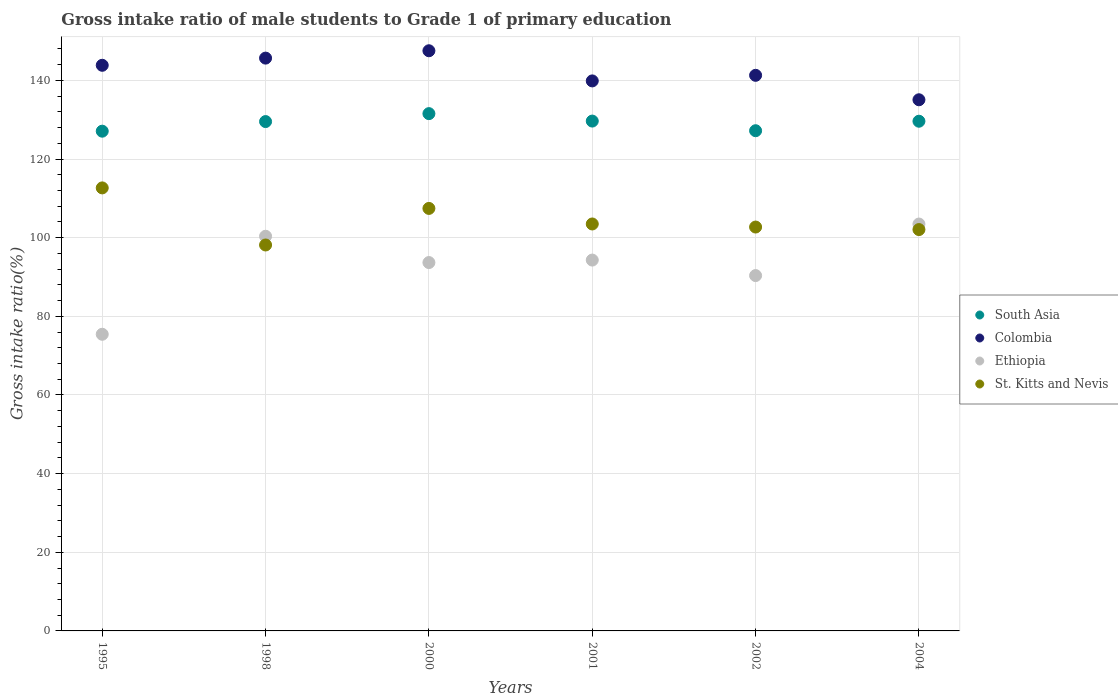How many different coloured dotlines are there?
Give a very brief answer. 4. What is the gross intake ratio in Ethiopia in 2000?
Keep it short and to the point. 93.67. Across all years, what is the maximum gross intake ratio in Colombia?
Offer a terse response. 147.53. Across all years, what is the minimum gross intake ratio in Ethiopia?
Offer a terse response. 75.43. In which year was the gross intake ratio in Ethiopia maximum?
Ensure brevity in your answer.  2004. What is the total gross intake ratio in St. Kitts and Nevis in the graph?
Provide a succinct answer. 626.48. What is the difference between the gross intake ratio in South Asia in 2000 and that in 2002?
Your answer should be very brief. 4.35. What is the difference between the gross intake ratio in Colombia in 2000 and the gross intake ratio in Ethiopia in 2001?
Provide a succinct answer. 53.23. What is the average gross intake ratio in Ethiopia per year?
Your answer should be very brief. 92.93. In the year 1995, what is the difference between the gross intake ratio in Colombia and gross intake ratio in South Asia?
Your answer should be compact. 16.76. What is the ratio of the gross intake ratio in St. Kitts and Nevis in 2000 to that in 2004?
Offer a very short reply. 1.05. Is the gross intake ratio in South Asia in 2000 less than that in 2004?
Offer a terse response. No. What is the difference between the highest and the second highest gross intake ratio in Colombia?
Give a very brief answer. 1.87. What is the difference between the highest and the lowest gross intake ratio in South Asia?
Provide a succinct answer. 4.46. Is the sum of the gross intake ratio in St. Kitts and Nevis in 1998 and 2000 greater than the maximum gross intake ratio in South Asia across all years?
Provide a short and direct response. Yes. Is the gross intake ratio in St. Kitts and Nevis strictly greater than the gross intake ratio in Colombia over the years?
Give a very brief answer. No. Does the graph contain grids?
Your answer should be very brief. Yes. Where does the legend appear in the graph?
Ensure brevity in your answer.  Center right. How many legend labels are there?
Make the answer very short. 4. How are the legend labels stacked?
Give a very brief answer. Vertical. What is the title of the graph?
Give a very brief answer. Gross intake ratio of male students to Grade 1 of primary education. What is the label or title of the Y-axis?
Your answer should be very brief. Gross intake ratio(%). What is the Gross intake ratio(%) of South Asia in 1995?
Give a very brief answer. 127.08. What is the Gross intake ratio(%) of Colombia in 1995?
Your answer should be very brief. 143.84. What is the Gross intake ratio(%) of Ethiopia in 1995?
Your answer should be compact. 75.43. What is the Gross intake ratio(%) in St. Kitts and Nevis in 1995?
Offer a terse response. 112.66. What is the Gross intake ratio(%) of South Asia in 1998?
Offer a very short reply. 129.52. What is the Gross intake ratio(%) in Colombia in 1998?
Make the answer very short. 145.66. What is the Gross intake ratio(%) in Ethiopia in 1998?
Provide a succinct answer. 100.36. What is the Gross intake ratio(%) of St. Kitts and Nevis in 1998?
Your answer should be compact. 98.14. What is the Gross intake ratio(%) in South Asia in 2000?
Make the answer very short. 131.54. What is the Gross intake ratio(%) of Colombia in 2000?
Offer a terse response. 147.53. What is the Gross intake ratio(%) of Ethiopia in 2000?
Make the answer very short. 93.67. What is the Gross intake ratio(%) in St. Kitts and Nevis in 2000?
Ensure brevity in your answer.  107.44. What is the Gross intake ratio(%) in South Asia in 2001?
Offer a very short reply. 129.65. What is the Gross intake ratio(%) of Colombia in 2001?
Keep it short and to the point. 139.86. What is the Gross intake ratio(%) of Ethiopia in 2001?
Provide a short and direct response. 94.31. What is the Gross intake ratio(%) of St. Kitts and Nevis in 2001?
Keep it short and to the point. 103.48. What is the Gross intake ratio(%) in South Asia in 2002?
Your answer should be very brief. 127.2. What is the Gross intake ratio(%) in Colombia in 2002?
Provide a short and direct response. 141.29. What is the Gross intake ratio(%) in Ethiopia in 2002?
Offer a very short reply. 90.36. What is the Gross intake ratio(%) of St. Kitts and Nevis in 2002?
Provide a succinct answer. 102.7. What is the Gross intake ratio(%) in South Asia in 2004?
Your answer should be compact. 129.61. What is the Gross intake ratio(%) of Colombia in 2004?
Your answer should be very brief. 135.07. What is the Gross intake ratio(%) in Ethiopia in 2004?
Your response must be concise. 103.47. What is the Gross intake ratio(%) of St. Kitts and Nevis in 2004?
Provide a succinct answer. 102.06. Across all years, what is the maximum Gross intake ratio(%) of South Asia?
Give a very brief answer. 131.54. Across all years, what is the maximum Gross intake ratio(%) of Colombia?
Provide a short and direct response. 147.53. Across all years, what is the maximum Gross intake ratio(%) in Ethiopia?
Your answer should be compact. 103.47. Across all years, what is the maximum Gross intake ratio(%) of St. Kitts and Nevis?
Offer a very short reply. 112.66. Across all years, what is the minimum Gross intake ratio(%) of South Asia?
Ensure brevity in your answer.  127.08. Across all years, what is the minimum Gross intake ratio(%) of Colombia?
Offer a terse response. 135.07. Across all years, what is the minimum Gross intake ratio(%) of Ethiopia?
Provide a short and direct response. 75.43. Across all years, what is the minimum Gross intake ratio(%) of St. Kitts and Nevis?
Make the answer very short. 98.14. What is the total Gross intake ratio(%) in South Asia in the graph?
Offer a terse response. 774.61. What is the total Gross intake ratio(%) in Colombia in the graph?
Keep it short and to the point. 853.25. What is the total Gross intake ratio(%) of Ethiopia in the graph?
Your response must be concise. 557.6. What is the total Gross intake ratio(%) of St. Kitts and Nevis in the graph?
Offer a terse response. 626.48. What is the difference between the Gross intake ratio(%) of South Asia in 1995 and that in 1998?
Give a very brief answer. -2.45. What is the difference between the Gross intake ratio(%) in Colombia in 1995 and that in 1998?
Provide a short and direct response. -1.82. What is the difference between the Gross intake ratio(%) of Ethiopia in 1995 and that in 1998?
Ensure brevity in your answer.  -24.93. What is the difference between the Gross intake ratio(%) of St. Kitts and Nevis in 1995 and that in 1998?
Provide a short and direct response. 14.52. What is the difference between the Gross intake ratio(%) of South Asia in 1995 and that in 2000?
Offer a very short reply. -4.46. What is the difference between the Gross intake ratio(%) of Colombia in 1995 and that in 2000?
Give a very brief answer. -3.7. What is the difference between the Gross intake ratio(%) in Ethiopia in 1995 and that in 2000?
Provide a short and direct response. -18.24. What is the difference between the Gross intake ratio(%) of St. Kitts and Nevis in 1995 and that in 2000?
Provide a short and direct response. 5.22. What is the difference between the Gross intake ratio(%) in South Asia in 1995 and that in 2001?
Provide a succinct answer. -2.57. What is the difference between the Gross intake ratio(%) in Colombia in 1995 and that in 2001?
Your answer should be compact. 3.97. What is the difference between the Gross intake ratio(%) of Ethiopia in 1995 and that in 2001?
Offer a terse response. -18.87. What is the difference between the Gross intake ratio(%) of St. Kitts and Nevis in 1995 and that in 2001?
Your response must be concise. 9.17. What is the difference between the Gross intake ratio(%) of South Asia in 1995 and that in 2002?
Make the answer very short. -0.12. What is the difference between the Gross intake ratio(%) in Colombia in 1995 and that in 2002?
Offer a very short reply. 2.55. What is the difference between the Gross intake ratio(%) in Ethiopia in 1995 and that in 2002?
Provide a succinct answer. -14.93. What is the difference between the Gross intake ratio(%) in St. Kitts and Nevis in 1995 and that in 2002?
Offer a very short reply. 9.95. What is the difference between the Gross intake ratio(%) of South Asia in 1995 and that in 2004?
Make the answer very short. -2.53. What is the difference between the Gross intake ratio(%) of Colombia in 1995 and that in 2004?
Keep it short and to the point. 8.77. What is the difference between the Gross intake ratio(%) of Ethiopia in 1995 and that in 2004?
Offer a terse response. -28.03. What is the difference between the Gross intake ratio(%) of St. Kitts and Nevis in 1995 and that in 2004?
Give a very brief answer. 10.59. What is the difference between the Gross intake ratio(%) in South Asia in 1998 and that in 2000?
Give a very brief answer. -2.02. What is the difference between the Gross intake ratio(%) of Colombia in 1998 and that in 2000?
Provide a succinct answer. -1.87. What is the difference between the Gross intake ratio(%) in Ethiopia in 1998 and that in 2000?
Ensure brevity in your answer.  6.69. What is the difference between the Gross intake ratio(%) in St. Kitts and Nevis in 1998 and that in 2000?
Give a very brief answer. -9.3. What is the difference between the Gross intake ratio(%) of South Asia in 1998 and that in 2001?
Give a very brief answer. -0.13. What is the difference between the Gross intake ratio(%) of Colombia in 1998 and that in 2001?
Your answer should be compact. 5.8. What is the difference between the Gross intake ratio(%) of Ethiopia in 1998 and that in 2001?
Ensure brevity in your answer.  6.05. What is the difference between the Gross intake ratio(%) in St. Kitts and Nevis in 1998 and that in 2001?
Give a very brief answer. -5.34. What is the difference between the Gross intake ratio(%) of South Asia in 1998 and that in 2002?
Give a very brief answer. 2.33. What is the difference between the Gross intake ratio(%) in Colombia in 1998 and that in 2002?
Provide a short and direct response. 4.37. What is the difference between the Gross intake ratio(%) of Ethiopia in 1998 and that in 2002?
Offer a very short reply. 10. What is the difference between the Gross intake ratio(%) of St. Kitts and Nevis in 1998 and that in 2002?
Offer a very short reply. -4.56. What is the difference between the Gross intake ratio(%) in South Asia in 1998 and that in 2004?
Offer a very short reply. -0.09. What is the difference between the Gross intake ratio(%) of Colombia in 1998 and that in 2004?
Your response must be concise. 10.59. What is the difference between the Gross intake ratio(%) in Ethiopia in 1998 and that in 2004?
Provide a succinct answer. -3.11. What is the difference between the Gross intake ratio(%) in St. Kitts and Nevis in 1998 and that in 2004?
Your answer should be compact. -3.92. What is the difference between the Gross intake ratio(%) in South Asia in 2000 and that in 2001?
Your response must be concise. 1.89. What is the difference between the Gross intake ratio(%) in Colombia in 2000 and that in 2001?
Offer a very short reply. 7.67. What is the difference between the Gross intake ratio(%) in Ethiopia in 2000 and that in 2001?
Your response must be concise. -0.63. What is the difference between the Gross intake ratio(%) of St. Kitts and Nevis in 2000 and that in 2001?
Keep it short and to the point. 3.95. What is the difference between the Gross intake ratio(%) of South Asia in 2000 and that in 2002?
Your answer should be very brief. 4.35. What is the difference between the Gross intake ratio(%) in Colombia in 2000 and that in 2002?
Your answer should be compact. 6.25. What is the difference between the Gross intake ratio(%) in Ethiopia in 2000 and that in 2002?
Ensure brevity in your answer.  3.31. What is the difference between the Gross intake ratio(%) in St. Kitts and Nevis in 2000 and that in 2002?
Provide a succinct answer. 4.74. What is the difference between the Gross intake ratio(%) in South Asia in 2000 and that in 2004?
Ensure brevity in your answer.  1.93. What is the difference between the Gross intake ratio(%) of Colombia in 2000 and that in 2004?
Your answer should be compact. 12.46. What is the difference between the Gross intake ratio(%) in Ethiopia in 2000 and that in 2004?
Ensure brevity in your answer.  -9.8. What is the difference between the Gross intake ratio(%) of St. Kitts and Nevis in 2000 and that in 2004?
Ensure brevity in your answer.  5.38. What is the difference between the Gross intake ratio(%) of South Asia in 2001 and that in 2002?
Offer a very short reply. 2.45. What is the difference between the Gross intake ratio(%) of Colombia in 2001 and that in 2002?
Offer a terse response. -1.42. What is the difference between the Gross intake ratio(%) in Ethiopia in 2001 and that in 2002?
Provide a short and direct response. 3.94. What is the difference between the Gross intake ratio(%) of St. Kitts and Nevis in 2001 and that in 2002?
Your response must be concise. 0.78. What is the difference between the Gross intake ratio(%) in South Asia in 2001 and that in 2004?
Provide a short and direct response. 0.04. What is the difference between the Gross intake ratio(%) of Colombia in 2001 and that in 2004?
Offer a very short reply. 4.79. What is the difference between the Gross intake ratio(%) of Ethiopia in 2001 and that in 2004?
Ensure brevity in your answer.  -9.16. What is the difference between the Gross intake ratio(%) of St. Kitts and Nevis in 2001 and that in 2004?
Give a very brief answer. 1.42. What is the difference between the Gross intake ratio(%) in South Asia in 2002 and that in 2004?
Make the answer very short. -2.42. What is the difference between the Gross intake ratio(%) in Colombia in 2002 and that in 2004?
Your answer should be very brief. 6.22. What is the difference between the Gross intake ratio(%) of Ethiopia in 2002 and that in 2004?
Ensure brevity in your answer.  -13.11. What is the difference between the Gross intake ratio(%) of St. Kitts and Nevis in 2002 and that in 2004?
Provide a short and direct response. 0.64. What is the difference between the Gross intake ratio(%) in South Asia in 1995 and the Gross intake ratio(%) in Colombia in 1998?
Make the answer very short. -18.58. What is the difference between the Gross intake ratio(%) in South Asia in 1995 and the Gross intake ratio(%) in Ethiopia in 1998?
Your response must be concise. 26.72. What is the difference between the Gross intake ratio(%) in South Asia in 1995 and the Gross intake ratio(%) in St. Kitts and Nevis in 1998?
Provide a short and direct response. 28.94. What is the difference between the Gross intake ratio(%) of Colombia in 1995 and the Gross intake ratio(%) of Ethiopia in 1998?
Provide a succinct answer. 43.48. What is the difference between the Gross intake ratio(%) in Colombia in 1995 and the Gross intake ratio(%) in St. Kitts and Nevis in 1998?
Your answer should be compact. 45.7. What is the difference between the Gross intake ratio(%) in Ethiopia in 1995 and the Gross intake ratio(%) in St. Kitts and Nevis in 1998?
Keep it short and to the point. -22.71. What is the difference between the Gross intake ratio(%) in South Asia in 1995 and the Gross intake ratio(%) in Colombia in 2000?
Your response must be concise. -20.45. What is the difference between the Gross intake ratio(%) of South Asia in 1995 and the Gross intake ratio(%) of Ethiopia in 2000?
Keep it short and to the point. 33.41. What is the difference between the Gross intake ratio(%) in South Asia in 1995 and the Gross intake ratio(%) in St. Kitts and Nevis in 2000?
Make the answer very short. 19.64. What is the difference between the Gross intake ratio(%) of Colombia in 1995 and the Gross intake ratio(%) of Ethiopia in 2000?
Your answer should be compact. 50.16. What is the difference between the Gross intake ratio(%) in Colombia in 1995 and the Gross intake ratio(%) in St. Kitts and Nevis in 2000?
Keep it short and to the point. 36.4. What is the difference between the Gross intake ratio(%) in Ethiopia in 1995 and the Gross intake ratio(%) in St. Kitts and Nevis in 2000?
Offer a terse response. -32. What is the difference between the Gross intake ratio(%) of South Asia in 1995 and the Gross intake ratio(%) of Colombia in 2001?
Your response must be concise. -12.79. What is the difference between the Gross intake ratio(%) in South Asia in 1995 and the Gross intake ratio(%) in Ethiopia in 2001?
Your answer should be very brief. 32.77. What is the difference between the Gross intake ratio(%) in South Asia in 1995 and the Gross intake ratio(%) in St. Kitts and Nevis in 2001?
Your answer should be compact. 23.6. What is the difference between the Gross intake ratio(%) in Colombia in 1995 and the Gross intake ratio(%) in Ethiopia in 2001?
Keep it short and to the point. 49.53. What is the difference between the Gross intake ratio(%) in Colombia in 1995 and the Gross intake ratio(%) in St. Kitts and Nevis in 2001?
Give a very brief answer. 40.35. What is the difference between the Gross intake ratio(%) in Ethiopia in 1995 and the Gross intake ratio(%) in St. Kitts and Nevis in 2001?
Keep it short and to the point. -28.05. What is the difference between the Gross intake ratio(%) in South Asia in 1995 and the Gross intake ratio(%) in Colombia in 2002?
Make the answer very short. -14.21. What is the difference between the Gross intake ratio(%) in South Asia in 1995 and the Gross intake ratio(%) in Ethiopia in 2002?
Offer a terse response. 36.72. What is the difference between the Gross intake ratio(%) of South Asia in 1995 and the Gross intake ratio(%) of St. Kitts and Nevis in 2002?
Provide a short and direct response. 24.38. What is the difference between the Gross intake ratio(%) in Colombia in 1995 and the Gross intake ratio(%) in Ethiopia in 2002?
Offer a terse response. 53.47. What is the difference between the Gross intake ratio(%) in Colombia in 1995 and the Gross intake ratio(%) in St. Kitts and Nevis in 2002?
Keep it short and to the point. 41.13. What is the difference between the Gross intake ratio(%) of Ethiopia in 1995 and the Gross intake ratio(%) of St. Kitts and Nevis in 2002?
Ensure brevity in your answer.  -27.27. What is the difference between the Gross intake ratio(%) of South Asia in 1995 and the Gross intake ratio(%) of Colombia in 2004?
Offer a terse response. -7.99. What is the difference between the Gross intake ratio(%) of South Asia in 1995 and the Gross intake ratio(%) of Ethiopia in 2004?
Provide a succinct answer. 23.61. What is the difference between the Gross intake ratio(%) of South Asia in 1995 and the Gross intake ratio(%) of St. Kitts and Nevis in 2004?
Provide a succinct answer. 25.02. What is the difference between the Gross intake ratio(%) of Colombia in 1995 and the Gross intake ratio(%) of Ethiopia in 2004?
Offer a terse response. 40.37. What is the difference between the Gross intake ratio(%) in Colombia in 1995 and the Gross intake ratio(%) in St. Kitts and Nevis in 2004?
Provide a short and direct response. 41.77. What is the difference between the Gross intake ratio(%) of Ethiopia in 1995 and the Gross intake ratio(%) of St. Kitts and Nevis in 2004?
Offer a very short reply. -26.63. What is the difference between the Gross intake ratio(%) in South Asia in 1998 and the Gross intake ratio(%) in Colombia in 2000?
Offer a very short reply. -18.01. What is the difference between the Gross intake ratio(%) of South Asia in 1998 and the Gross intake ratio(%) of Ethiopia in 2000?
Provide a short and direct response. 35.85. What is the difference between the Gross intake ratio(%) of South Asia in 1998 and the Gross intake ratio(%) of St. Kitts and Nevis in 2000?
Give a very brief answer. 22.09. What is the difference between the Gross intake ratio(%) of Colombia in 1998 and the Gross intake ratio(%) of Ethiopia in 2000?
Ensure brevity in your answer.  51.99. What is the difference between the Gross intake ratio(%) of Colombia in 1998 and the Gross intake ratio(%) of St. Kitts and Nevis in 2000?
Provide a short and direct response. 38.22. What is the difference between the Gross intake ratio(%) of Ethiopia in 1998 and the Gross intake ratio(%) of St. Kitts and Nevis in 2000?
Your answer should be very brief. -7.08. What is the difference between the Gross intake ratio(%) of South Asia in 1998 and the Gross intake ratio(%) of Colombia in 2001?
Provide a short and direct response. -10.34. What is the difference between the Gross intake ratio(%) in South Asia in 1998 and the Gross intake ratio(%) in Ethiopia in 2001?
Offer a very short reply. 35.22. What is the difference between the Gross intake ratio(%) of South Asia in 1998 and the Gross intake ratio(%) of St. Kitts and Nevis in 2001?
Keep it short and to the point. 26.04. What is the difference between the Gross intake ratio(%) in Colombia in 1998 and the Gross intake ratio(%) in Ethiopia in 2001?
Keep it short and to the point. 51.35. What is the difference between the Gross intake ratio(%) of Colombia in 1998 and the Gross intake ratio(%) of St. Kitts and Nevis in 2001?
Provide a succinct answer. 42.18. What is the difference between the Gross intake ratio(%) in Ethiopia in 1998 and the Gross intake ratio(%) in St. Kitts and Nevis in 2001?
Ensure brevity in your answer.  -3.12. What is the difference between the Gross intake ratio(%) in South Asia in 1998 and the Gross intake ratio(%) in Colombia in 2002?
Provide a short and direct response. -11.76. What is the difference between the Gross intake ratio(%) of South Asia in 1998 and the Gross intake ratio(%) of Ethiopia in 2002?
Offer a terse response. 39.16. What is the difference between the Gross intake ratio(%) in South Asia in 1998 and the Gross intake ratio(%) in St. Kitts and Nevis in 2002?
Your response must be concise. 26.82. What is the difference between the Gross intake ratio(%) in Colombia in 1998 and the Gross intake ratio(%) in Ethiopia in 2002?
Provide a succinct answer. 55.3. What is the difference between the Gross intake ratio(%) of Colombia in 1998 and the Gross intake ratio(%) of St. Kitts and Nevis in 2002?
Provide a short and direct response. 42.96. What is the difference between the Gross intake ratio(%) of Ethiopia in 1998 and the Gross intake ratio(%) of St. Kitts and Nevis in 2002?
Ensure brevity in your answer.  -2.34. What is the difference between the Gross intake ratio(%) of South Asia in 1998 and the Gross intake ratio(%) of Colombia in 2004?
Your answer should be very brief. -5.54. What is the difference between the Gross intake ratio(%) in South Asia in 1998 and the Gross intake ratio(%) in Ethiopia in 2004?
Provide a succinct answer. 26.06. What is the difference between the Gross intake ratio(%) in South Asia in 1998 and the Gross intake ratio(%) in St. Kitts and Nevis in 2004?
Offer a very short reply. 27.46. What is the difference between the Gross intake ratio(%) in Colombia in 1998 and the Gross intake ratio(%) in Ethiopia in 2004?
Provide a short and direct response. 42.19. What is the difference between the Gross intake ratio(%) in Colombia in 1998 and the Gross intake ratio(%) in St. Kitts and Nevis in 2004?
Provide a short and direct response. 43.6. What is the difference between the Gross intake ratio(%) in Ethiopia in 1998 and the Gross intake ratio(%) in St. Kitts and Nevis in 2004?
Your answer should be compact. -1.7. What is the difference between the Gross intake ratio(%) of South Asia in 2000 and the Gross intake ratio(%) of Colombia in 2001?
Give a very brief answer. -8.32. What is the difference between the Gross intake ratio(%) in South Asia in 2000 and the Gross intake ratio(%) in Ethiopia in 2001?
Provide a succinct answer. 37.24. What is the difference between the Gross intake ratio(%) of South Asia in 2000 and the Gross intake ratio(%) of St. Kitts and Nevis in 2001?
Your answer should be very brief. 28.06. What is the difference between the Gross intake ratio(%) in Colombia in 2000 and the Gross intake ratio(%) in Ethiopia in 2001?
Offer a very short reply. 53.23. What is the difference between the Gross intake ratio(%) in Colombia in 2000 and the Gross intake ratio(%) in St. Kitts and Nevis in 2001?
Provide a succinct answer. 44.05. What is the difference between the Gross intake ratio(%) in Ethiopia in 2000 and the Gross intake ratio(%) in St. Kitts and Nevis in 2001?
Provide a succinct answer. -9.81. What is the difference between the Gross intake ratio(%) of South Asia in 2000 and the Gross intake ratio(%) of Colombia in 2002?
Your answer should be compact. -9.74. What is the difference between the Gross intake ratio(%) of South Asia in 2000 and the Gross intake ratio(%) of Ethiopia in 2002?
Offer a very short reply. 41.18. What is the difference between the Gross intake ratio(%) of South Asia in 2000 and the Gross intake ratio(%) of St. Kitts and Nevis in 2002?
Provide a short and direct response. 28.84. What is the difference between the Gross intake ratio(%) of Colombia in 2000 and the Gross intake ratio(%) of Ethiopia in 2002?
Your answer should be compact. 57.17. What is the difference between the Gross intake ratio(%) of Colombia in 2000 and the Gross intake ratio(%) of St. Kitts and Nevis in 2002?
Provide a short and direct response. 44.83. What is the difference between the Gross intake ratio(%) of Ethiopia in 2000 and the Gross intake ratio(%) of St. Kitts and Nevis in 2002?
Give a very brief answer. -9.03. What is the difference between the Gross intake ratio(%) of South Asia in 2000 and the Gross intake ratio(%) of Colombia in 2004?
Provide a short and direct response. -3.53. What is the difference between the Gross intake ratio(%) of South Asia in 2000 and the Gross intake ratio(%) of Ethiopia in 2004?
Your answer should be very brief. 28.07. What is the difference between the Gross intake ratio(%) in South Asia in 2000 and the Gross intake ratio(%) in St. Kitts and Nevis in 2004?
Your response must be concise. 29.48. What is the difference between the Gross intake ratio(%) in Colombia in 2000 and the Gross intake ratio(%) in Ethiopia in 2004?
Offer a very short reply. 44.07. What is the difference between the Gross intake ratio(%) in Colombia in 2000 and the Gross intake ratio(%) in St. Kitts and Nevis in 2004?
Ensure brevity in your answer.  45.47. What is the difference between the Gross intake ratio(%) in Ethiopia in 2000 and the Gross intake ratio(%) in St. Kitts and Nevis in 2004?
Provide a succinct answer. -8.39. What is the difference between the Gross intake ratio(%) of South Asia in 2001 and the Gross intake ratio(%) of Colombia in 2002?
Your response must be concise. -11.64. What is the difference between the Gross intake ratio(%) in South Asia in 2001 and the Gross intake ratio(%) in Ethiopia in 2002?
Your answer should be compact. 39.29. What is the difference between the Gross intake ratio(%) of South Asia in 2001 and the Gross intake ratio(%) of St. Kitts and Nevis in 2002?
Make the answer very short. 26.95. What is the difference between the Gross intake ratio(%) in Colombia in 2001 and the Gross intake ratio(%) in Ethiopia in 2002?
Provide a short and direct response. 49.5. What is the difference between the Gross intake ratio(%) of Colombia in 2001 and the Gross intake ratio(%) of St. Kitts and Nevis in 2002?
Make the answer very short. 37.16. What is the difference between the Gross intake ratio(%) of Ethiopia in 2001 and the Gross intake ratio(%) of St. Kitts and Nevis in 2002?
Your response must be concise. -8.4. What is the difference between the Gross intake ratio(%) in South Asia in 2001 and the Gross intake ratio(%) in Colombia in 2004?
Offer a terse response. -5.42. What is the difference between the Gross intake ratio(%) in South Asia in 2001 and the Gross intake ratio(%) in Ethiopia in 2004?
Offer a terse response. 26.18. What is the difference between the Gross intake ratio(%) in South Asia in 2001 and the Gross intake ratio(%) in St. Kitts and Nevis in 2004?
Offer a terse response. 27.59. What is the difference between the Gross intake ratio(%) in Colombia in 2001 and the Gross intake ratio(%) in Ethiopia in 2004?
Give a very brief answer. 36.4. What is the difference between the Gross intake ratio(%) of Colombia in 2001 and the Gross intake ratio(%) of St. Kitts and Nevis in 2004?
Provide a short and direct response. 37.8. What is the difference between the Gross intake ratio(%) in Ethiopia in 2001 and the Gross intake ratio(%) in St. Kitts and Nevis in 2004?
Your answer should be very brief. -7.76. What is the difference between the Gross intake ratio(%) of South Asia in 2002 and the Gross intake ratio(%) of Colombia in 2004?
Keep it short and to the point. -7.87. What is the difference between the Gross intake ratio(%) of South Asia in 2002 and the Gross intake ratio(%) of Ethiopia in 2004?
Make the answer very short. 23.73. What is the difference between the Gross intake ratio(%) in South Asia in 2002 and the Gross intake ratio(%) in St. Kitts and Nevis in 2004?
Provide a short and direct response. 25.14. What is the difference between the Gross intake ratio(%) in Colombia in 2002 and the Gross intake ratio(%) in Ethiopia in 2004?
Offer a very short reply. 37.82. What is the difference between the Gross intake ratio(%) of Colombia in 2002 and the Gross intake ratio(%) of St. Kitts and Nevis in 2004?
Your answer should be very brief. 39.22. What is the difference between the Gross intake ratio(%) in Ethiopia in 2002 and the Gross intake ratio(%) in St. Kitts and Nevis in 2004?
Give a very brief answer. -11.7. What is the average Gross intake ratio(%) of South Asia per year?
Keep it short and to the point. 129.1. What is the average Gross intake ratio(%) in Colombia per year?
Your answer should be very brief. 142.21. What is the average Gross intake ratio(%) of Ethiopia per year?
Keep it short and to the point. 92.93. What is the average Gross intake ratio(%) of St. Kitts and Nevis per year?
Your answer should be compact. 104.41. In the year 1995, what is the difference between the Gross intake ratio(%) of South Asia and Gross intake ratio(%) of Colombia?
Keep it short and to the point. -16.76. In the year 1995, what is the difference between the Gross intake ratio(%) of South Asia and Gross intake ratio(%) of Ethiopia?
Offer a terse response. 51.64. In the year 1995, what is the difference between the Gross intake ratio(%) in South Asia and Gross intake ratio(%) in St. Kitts and Nevis?
Ensure brevity in your answer.  14.42. In the year 1995, what is the difference between the Gross intake ratio(%) in Colombia and Gross intake ratio(%) in Ethiopia?
Your answer should be compact. 68.4. In the year 1995, what is the difference between the Gross intake ratio(%) of Colombia and Gross intake ratio(%) of St. Kitts and Nevis?
Give a very brief answer. 31.18. In the year 1995, what is the difference between the Gross intake ratio(%) of Ethiopia and Gross intake ratio(%) of St. Kitts and Nevis?
Keep it short and to the point. -37.22. In the year 1998, what is the difference between the Gross intake ratio(%) of South Asia and Gross intake ratio(%) of Colombia?
Your answer should be very brief. -16.14. In the year 1998, what is the difference between the Gross intake ratio(%) in South Asia and Gross intake ratio(%) in Ethiopia?
Your answer should be very brief. 29.16. In the year 1998, what is the difference between the Gross intake ratio(%) of South Asia and Gross intake ratio(%) of St. Kitts and Nevis?
Provide a succinct answer. 31.38. In the year 1998, what is the difference between the Gross intake ratio(%) of Colombia and Gross intake ratio(%) of Ethiopia?
Make the answer very short. 45.3. In the year 1998, what is the difference between the Gross intake ratio(%) of Colombia and Gross intake ratio(%) of St. Kitts and Nevis?
Keep it short and to the point. 47.52. In the year 1998, what is the difference between the Gross intake ratio(%) in Ethiopia and Gross intake ratio(%) in St. Kitts and Nevis?
Your answer should be compact. 2.22. In the year 2000, what is the difference between the Gross intake ratio(%) of South Asia and Gross intake ratio(%) of Colombia?
Your answer should be very brief. -15.99. In the year 2000, what is the difference between the Gross intake ratio(%) of South Asia and Gross intake ratio(%) of Ethiopia?
Provide a short and direct response. 37.87. In the year 2000, what is the difference between the Gross intake ratio(%) in South Asia and Gross intake ratio(%) in St. Kitts and Nevis?
Give a very brief answer. 24.1. In the year 2000, what is the difference between the Gross intake ratio(%) of Colombia and Gross intake ratio(%) of Ethiopia?
Your response must be concise. 53.86. In the year 2000, what is the difference between the Gross intake ratio(%) in Colombia and Gross intake ratio(%) in St. Kitts and Nevis?
Offer a very short reply. 40.09. In the year 2000, what is the difference between the Gross intake ratio(%) in Ethiopia and Gross intake ratio(%) in St. Kitts and Nevis?
Give a very brief answer. -13.77. In the year 2001, what is the difference between the Gross intake ratio(%) of South Asia and Gross intake ratio(%) of Colombia?
Make the answer very short. -10.21. In the year 2001, what is the difference between the Gross intake ratio(%) of South Asia and Gross intake ratio(%) of Ethiopia?
Provide a short and direct response. 35.34. In the year 2001, what is the difference between the Gross intake ratio(%) in South Asia and Gross intake ratio(%) in St. Kitts and Nevis?
Your response must be concise. 26.17. In the year 2001, what is the difference between the Gross intake ratio(%) of Colombia and Gross intake ratio(%) of Ethiopia?
Your response must be concise. 45.56. In the year 2001, what is the difference between the Gross intake ratio(%) in Colombia and Gross intake ratio(%) in St. Kitts and Nevis?
Your answer should be very brief. 36.38. In the year 2001, what is the difference between the Gross intake ratio(%) in Ethiopia and Gross intake ratio(%) in St. Kitts and Nevis?
Your answer should be compact. -9.18. In the year 2002, what is the difference between the Gross intake ratio(%) in South Asia and Gross intake ratio(%) in Colombia?
Offer a very short reply. -14.09. In the year 2002, what is the difference between the Gross intake ratio(%) in South Asia and Gross intake ratio(%) in Ethiopia?
Your answer should be very brief. 36.83. In the year 2002, what is the difference between the Gross intake ratio(%) in South Asia and Gross intake ratio(%) in St. Kitts and Nevis?
Give a very brief answer. 24.49. In the year 2002, what is the difference between the Gross intake ratio(%) in Colombia and Gross intake ratio(%) in Ethiopia?
Give a very brief answer. 50.92. In the year 2002, what is the difference between the Gross intake ratio(%) in Colombia and Gross intake ratio(%) in St. Kitts and Nevis?
Keep it short and to the point. 38.58. In the year 2002, what is the difference between the Gross intake ratio(%) in Ethiopia and Gross intake ratio(%) in St. Kitts and Nevis?
Keep it short and to the point. -12.34. In the year 2004, what is the difference between the Gross intake ratio(%) of South Asia and Gross intake ratio(%) of Colombia?
Your answer should be compact. -5.46. In the year 2004, what is the difference between the Gross intake ratio(%) in South Asia and Gross intake ratio(%) in Ethiopia?
Give a very brief answer. 26.14. In the year 2004, what is the difference between the Gross intake ratio(%) in South Asia and Gross intake ratio(%) in St. Kitts and Nevis?
Ensure brevity in your answer.  27.55. In the year 2004, what is the difference between the Gross intake ratio(%) of Colombia and Gross intake ratio(%) of Ethiopia?
Ensure brevity in your answer.  31.6. In the year 2004, what is the difference between the Gross intake ratio(%) in Colombia and Gross intake ratio(%) in St. Kitts and Nevis?
Provide a short and direct response. 33.01. In the year 2004, what is the difference between the Gross intake ratio(%) in Ethiopia and Gross intake ratio(%) in St. Kitts and Nevis?
Offer a terse response. 1.41. What is the ratio of the Gross intake ratio(%) of South Asia in 1995 to that in 1998?
Keep it short and to the point. 0.98. What is the ratio of the Gross intake ratio(%) in Colombia in 1995 to that in 1998?
Provide a short and direct response. 0.99. What is the ratio of the Gross intake ratio(%) of Ethiopia in 1995 to that in 1998?
Offer a very short reply. 0.75. What is the ratio of the Gross intake ratio(%) of St. Kitts and Nevis in 1995 to that in 1998?
Give a very brief answer. 1.15. What is the ratio of the Gross intake ratio(%) of South Asia in 1995 to that in 2000?
Offer a very short reply. 0.97. What is the ratio of the Gross intake ratio(%) in Colombia in 1995 to that in 2000?
Your answer should be very brief. 0.97. What is the ratio of the Gross intake ratio(%) in Ethiopia in 1995 to that in 2000?
Offer a very short reply. 0.81. What is the ratio of the Gross intake ratio(%) in St. Kitts and Nevis in 1995 to that in 2000?
Give a very brief answer. 1.05. What is the ratio of the Gross intake ratio(%) in South Asia in 1995 to that in 2001?
Ensure brevity in your answer.  0.98. What is the ratio of the Gross intake ratio(%) in Colombia in 1995 to that in 2001?
Offer a terse response. 1.03. What is the ratio of the Gross intake ratio(%) of Ethiopia in 1995 to that in 2001?
Your answer should be compact. 0.8. What is the ratio of the Gross intake ratio(%) in St. Kitts and Nevis in 1995 to that in 2001?
Ensure brevity in your answer.  1.09. What is the ratio of the Gross intake ratio(%) in South Asia in 1995 to that in 2002?
Your response must be concise. 1. What is the ratio of the Gross intake ratio(%) of Colombia in 1995 to that in 2002?
Offer a very short reply. 1.02. What is the ratio of the Gross intake ratio(%) of Ethiopia in 1995 to that in 2002?
Your response must be concise. 0.83. What is the ratio of the Gross intake ratio(%) in St. Kitts and Nevis in 1995 to that in 2002?
Provide a succinct answer. 1.1. What is the ratio of the Gross intake ratio(%) of South Asia in 1995 to that in 2004?
Ensure brevity in your answer.  0.98. What is the ratio of the Gross intake ratio(%) in Colombia in 1995 to that in 2004?
Provide a short and direct response. 1.06. What is the ratio of the Gross intake ratio(%) of Ethiopia in 1995 to that in 2004?
Keep it short and to the point. 0.73. What is the ratio of the Gross intake ratio(%) in St. Kitts and Nevis in 1995 to that in 2004?
Provide a succinct answer. 1.1. What is the ratio of the Gross intake ratio(%) in South Asia in 1998 to that in 2000?
Ensure brevity in your answer.  0.98. What is the ratio of the Gross intake ratio(%) in Colombia in 1998 to that in 2000?
Give a very brief answer. 0.99. What is the ratio of the Gross intake ratio(%) of Ethiopia in 1998 to that in 2000?
Your answer should be compact. 1.07. What is the ratio of the Gross intake ratio(%) in St. Kitts and Nevis in 1998 to that in 2000?
Your response must be concise. 0.91. What is the ratio of the Gross intake ratio(%) of Colombia in 1998 to that in 2001?
Keep it short and to the point. 1.04. What is the ratio of the Gross intake ratio(%) of Ethiopia in 1998 to that in 2001?
Provide a short and direct response. 1.06. What is the ratio of the Gross intake ratio(%) of St. Kitts and Nevis in 1998 to that in 2001?
Provide a succinct answer. 0.95. What is the ratio of the Gross intake ratio(%) in South Asia in 1998 to that in 2002?
Your response must be concise. 1.02. What is the ratio of the Gross intake ratio(%) in Colombia in 1998 to that in 2002?
Your answer should be very brief. 1.03. What is the ratio of the Gross intake ratio(%) in Ethiopia in 1998 to that in 2002?
Offer a terse response. 1.11. What is the ratio of the Gross intake ratio(%) in St. Kitts and Nevis in 1998 to that in 2002?
Provide a succinct answer. 0.96. What is the ratio of the Gross intake ratio(%) in Colombia in 1998 to that in 2004?
Make the answer very short. 1.08. What is the ratio of the Gross intake ratio(%) of St. Kitts and Nevis in 1998 to that in 2004?
Your answer should be very brief. 0.96. What is the ratio of the Gross intake ratio(%) in South Asia in 2000 to that in 2001?
Provide a succinct answer. 1.01. What is the ratio of the Gross intake ratio(%) of Colombia in 2000 to that in 2001?
Provide a succinct answer. 1.05. What is the ratio of the Gross intake ratio(%) of St. Kitts and Nevis in 2000 to that in 2001?
Your response must be concise. 1.04. What is the ratio of the Gross intake ratio(%) of South Asia in 2000 to that in 2002?
Keep it short and to the point. 1.03. What is the ratio of the Gross intake ratio(%) of Colombia in 2000 to that in 2002?
Offer a very short reply. 1.04. What is the ratio of the Gross intake ratio(%) in Ethiopia in 2000 to that in 2002?
Give a very brief answer. 1.04. What is the ratio of the Gross intake ratio(%) of St. Kitts and Nevis in 2000 to that in 2002?
Provide a short and direct response. 1.05. What is the ratio of the Gross intake ratio(%) in South Asia in 2000 to that in 2004?
Offer a terse response. 1.01. What is the ratio of the Gross intake ratio(%) of Colombia in 2000 to that in 2004?
Make the answer very short. 1.09. What is the ratio of the Gross intake ratio(%) of Ethiopia in 2000 to that in 2004?
Give a very brief answer. 0.91. What is the ratio of the Gross intake ratio(%) of St. Kitts and Nevis in 2000 to that in 2004?
Your response must be concise. 1.05. What is the ratio of the Gross intake ratio(%) of South Asia in 2001 to that in 2002?
Keep it short and to the point. 1.02. What is the ratio of the Gross intake ratio(%) in Ethiopia in 2001 to that in 2002?
Keep it short and to the point. 1.04. What is the ratio of the Gross intake ratio(%) in St. Kitts and Nevis in 2001 to that in 2002?
Provide a short and direct response. 1.01. What is the ratio of the Gross intake ratio(%) in South Asia in 2001 to that in 2004?
Make the answer very short. 1. What is the ratio of the Gross intake ratio(%) in Colombia in 2001 to that in 2004?
Your answer should be very brief. 1.04. What is the ratio of the Gross intake ratio(%) of Ethiopia in 2001 to that in 2004?
Give a very brief answer. 0.91. What is the ratio of the Gross intake ratio(%) of St. Kitts and Nevis in 2001 to that in 2004?
Give a very brief answer. 1.01. What is the ratio of the Gross intake ratio(%) of South Asia in 2002 to that in 2004?
Give a very brief answer. 0.98. What is the ratio of the Gross intake ratio(%) in Colombia in 2002 to that in 2004?
Your answer should be very brief. 1.05. What is the ratio of the Gross intake ratio(%) in Ethiopia in 2002 to that in 2004?
Offer a very short reply. 0.87. What is the difference between the highest and the second highest Gross intake ratio(%) in South Asia?
Offer a terse response. 1.89. What is the difference between the highest and the second highest Gross intake ratio(%) of Colombia?
Your answer should be compact. 1.87. What is the difference between the highest and the second highest Gross intake ratio(%) of Ethiopia?
Your answer should be very brief. 3.11. What is the difference between the highest and the second highest Gross intake ratio(%) of St. Kitts and Nevis?
Provide a short and direct response. 5.22. What is the difference between the highest and the lowest Gross intake ratio(%) in South Asia?
Ensure brevity in your answer.  4.46. What is the difference between the highest and the lowest Gross intake ratio(%) in Colombia?
Make the answer very short. 12.46. What is the difference between the highest and the lowest Gross intake ratio(%) in Ethiopia?
Your answer should be very brief. 28.03. What is the difference between the highest and the lowest Gross intake ratio(%) of St. Kitts and Nevis?
Make the answer very short. 14.52. 